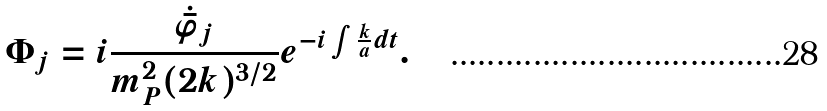Convert formula to latex. <formula><loc_0><loc_0><loc_500><loc_500>\Phi _ { j } = i \frac { \dot { \bar { \varphi } } _ { j } } { m _ { P } ^ { 2 } ( 2 k ) ^ { 3 / 2 } } e ^ { - i \int \frac { k } { a } d t } .</formula> 